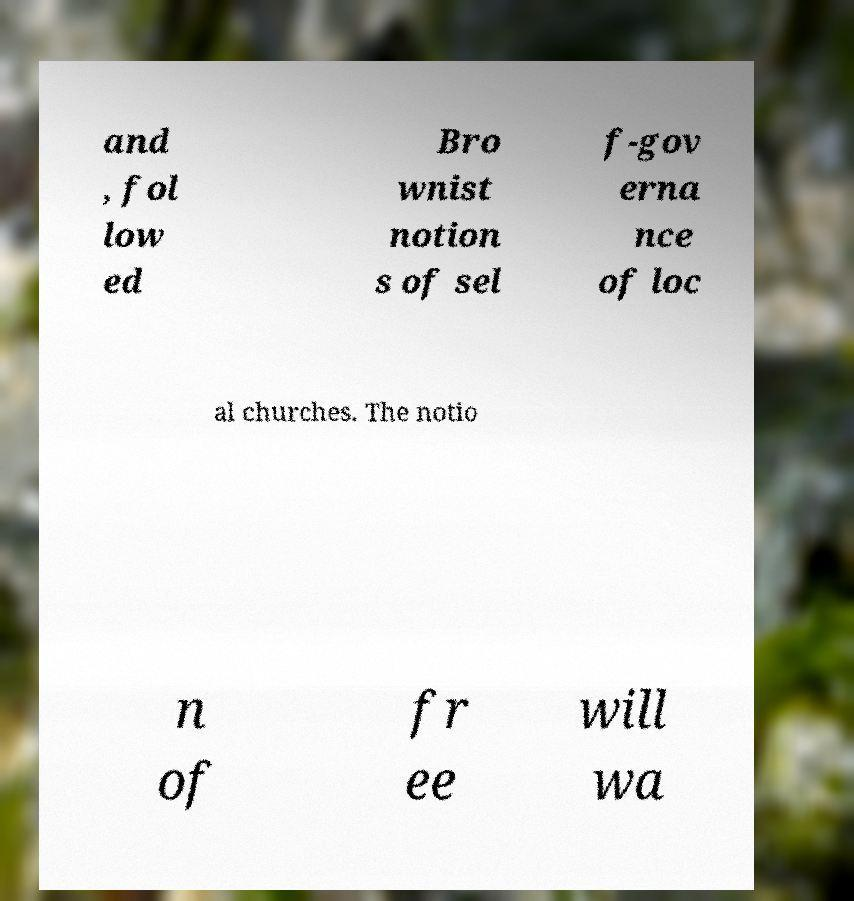Can you read and provide the text displayed in the image?This photo seems to have some interesting text. Can you extract and type it out for me? and , fol low ed Bro wnist notion s of sel f-gov erna nce of loc al churches. The notio n of fr ee will wa 